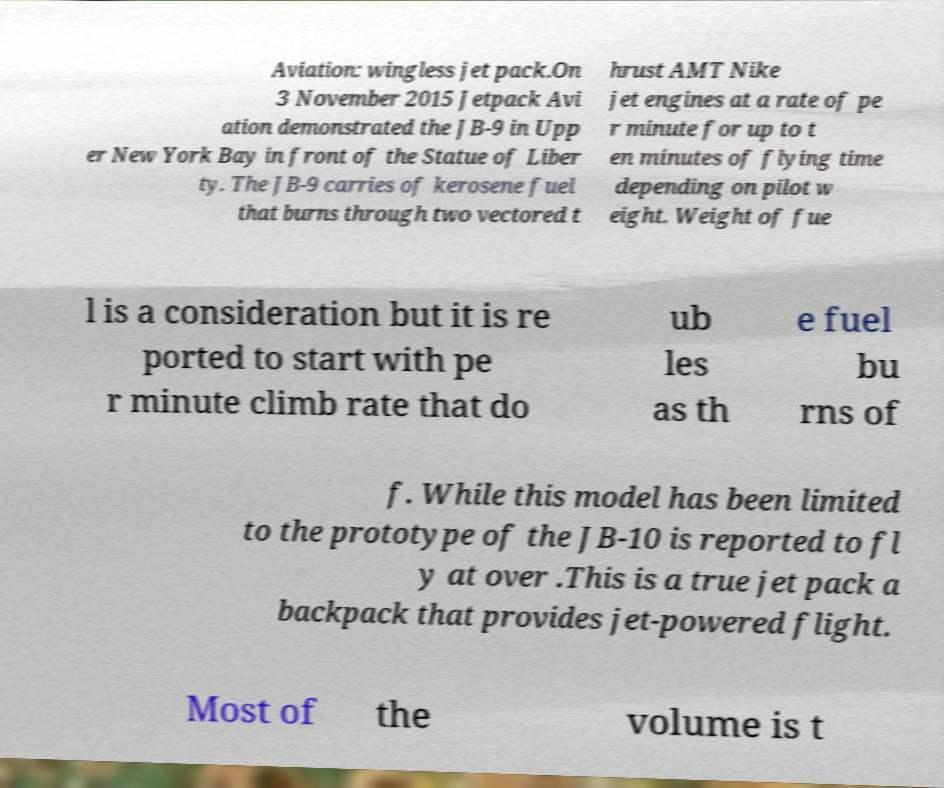There's text embedded in this image that I need extracted. Can you transcribe it verbatim? Aviation: wingless jet pack.On 3 November 2015 Jetpack Avi ation demonstrated the JB-9 in Upp er New York Bay in front of the Statue of Liber ty. The JB-9 carries of kerosene fuel that burns through two vectored t hrust AMT Nike jet engines at a rate of pe r minute for up to t en minutes of flying time depending on pilot w eight. Weight of fue l is a consideration but it is re ported to start with pe r minute climb rate that do ub les as th e fuel bu rns of f. While this model has been limited to the prototype of the JB-10 is reported to fl y at over .This is a true jet pack a backpack that provides jet-powered flight. Most of the volume is t 